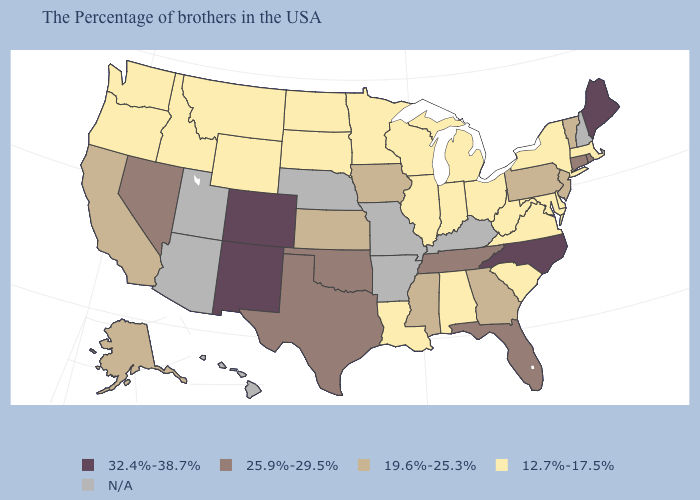Among the states that border Rhode Island , which have the highest value?
Write a very short answer. Connecticut. What is the value of Idaho?
Answer briefly. 12.7%-17.5%. Name the states that have a value in the range 25.9%-29.5%?
Give a very brief answer. Rhode Island, Connecticut, Florida, Tennessee, Oklahoma, Texas, Nevada. Does the first symbol in the legend represent the smallest category?
Be succinct. No. Which states hav the highest value in the Northeast?
Be succinct. Maine. What is the lowest value in states that border Iowa?
Answer briefly. 12.7%-17.5%. Name the states that have a value in the range 25.9%-29.5%?
Write a very short answer. Rhode Island, Connecticut, Florida, Tennessee, Oklahoma, Texas, Nevada. Does Tennessee have the highest value in the USA?
Be succinct. No. What is the value of West Virginia?
Concise answer only. 12.7%-17.5%. What is the value of Pennsylvania?
Write a very short answer. 19.6%-25.3%. What is the value of Illinois?
Quick response, please. 12.7%-17.5%. What is the value of Wyoming?
Concise answer only. 12.7%-17.5%. Which states hav the highest value in the Northeast?
Keep it brief. Maine. Among the states that border Kansas , does Oklahoma have the lowest value?
Short answer required. Yes. 